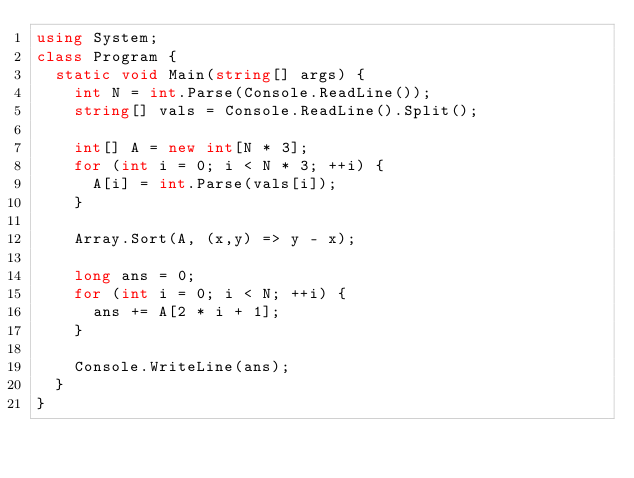Convert code to text. <code><loc_0><loc_0><loc_500><loc_500><_C#_>using System;
class Program {
  static void Main(string[] args) {
    int N = int.Parse(Console.ReadLine());
    string[] vals = Console.ReadLine().Split();

    int[] A = new int[N * 3];
    for (int i = 0; i < N * 3; ++i) {
      A[i] = int.Parse(vals[i]);
    }

    Array.Sort(A, (x,y) => y - x);

    long ans = 0;
    for (int i = 0; i < N; ++i) {
      ans += A[2 * i + 1];
    }

    Console.WriteLine(ans);
  }
}
</code> 